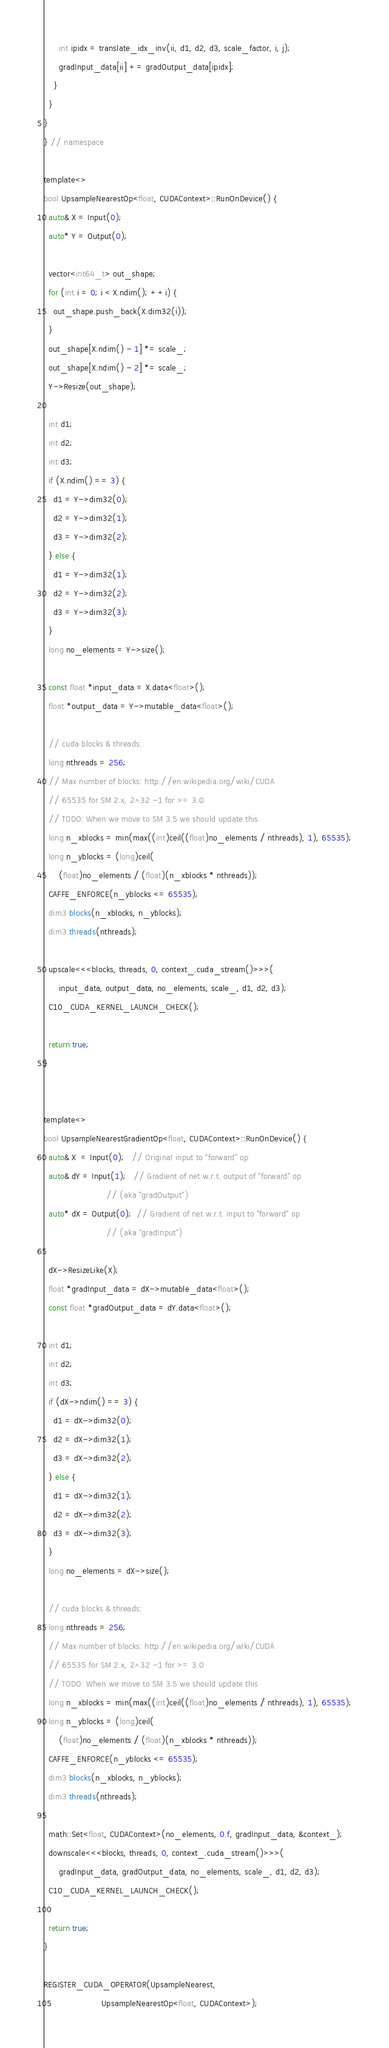<code> <loc_0><loc_0><loc_500><loc_500><_Cuda_>      int ipidx = translate_idx_inv(ii, d1, d2, d3, scale_factor, i, j);
      gradInput_data[ii] += gradOutput_data[ipidx];
    }
  }
}
} // namespace

template<>
bool UpsampleNearestOp<float, CUDAContext>::RunOnDevice() {
  auto& X = Input(0);
  auto* Y = Output(0);

  vector<int64_t> out_shape;
  for (int i = 0; i < X.ndim(); ++i) {
    out_shape.push_back(X.dim32(i));
  }
  out_shape[X.ndim() - 1] *= scale_;
  out_shape[X.ndim() - 2] *= scale_;
  Y->Resize(out_shape);

  int d1;
  int d2;
  int d3;
  if (X.ndim() == 3) {
    d1 = Y->dim32(0);
    d2 = Y->dim32(1);
    d3 = Y->dim32(2);
  } else {
    d1 = Y->dim32(1);
    d2 = Y->dim32(2);
    d3 = Y->dim32(3);
  }
  long no_elements = Y->size();

  const float *input_data = X.data<float>();
  float *output_data = Y->mutable_data<float>();

  // cuda blocks & threads:
  long nthreads = 256;
  // Max number of blocks: http://en.wikipedia.org/wiki/CUDA
  // 65535 for SM 2.x, 2^32 -1 for >= 3.0
  // TODO: When we move to SM 3.5 we should update this
  long n_xblocks = min(max((int)ceil((float)no_elements / nthreads), 1), 65535);
  long n_yblocks = (long)ceil(
      (float)no_elements / (float)(n_xblocks * nthreads));
  CAFFE_ENFORCE(n_yblocks <= 65535);
  dim3 blocks(n_xblocks, n_yblocks);
  dim3 threads(nthreads);

  upscale<<<blocks, threads, 0, context_.cuda_stream()>>>(
      input_data, output_data, no_elements, scale_, d1, d2, d3);
  C10_CUDA_KERNEL_LAUNCH_CHECK();

  return true;
}


template<>
bool UpsampleNearestGradientOp<float, CUDAContext>::RunOnDevice() {
  auto& X  = Input(0);   // Original input to "forward" op
  auto& dY = Input(1);   // Gradient of net w.r.t. output of "forward" op
                         // (aka "gradOutput")
  auto* dX = Output(0);  // Gradient of net w.r.t. input to "forward" op
                         // (aka "gradInput")

  dX->ResizeLike(X);
  float *gradInput_data = dX->mutable_data<float>();
  const float *gradOutput_data = dY.data<float>();

  int d1;
  int d2;
  int d3;
  if (dX->ndim() == 3) {
    d1 = dX->dim32(0);
    d2 = dX->dim32(1);
    d3 = dX->dim32(2);
  } else {
    d1 = dX->dim32(1);
    d2 = dX->dim32(2);
    d3 = dX->dim32(3);
  }
  long no_elements = dX->size();

  // cuda blocks & threads:
  long nthreads = 256;
  // Max number of blocks: http://en.wikipedia.org/wiki/CUDA
  // 65535 for SM 2.x, 2^32 -1 for >= 3.0
  // TODO: When we move to SM 3.5 we should update this
  long n_xblocks = min(max((int)ceil((float)no_elements / nthreads), 1), 65535);
  long n_yblocks = (long)ceil(
      (float)no_elements / (float)(n_xblocks * nthreads));
  CAFFE_ENFORCE(n_yblocks <= 65535);
  dim3 blocks(n_xblocks, n_yblocks);
  dim3 threads(nthreads);

  math::Set<float, CUDAContext>(no_elements, 0.f, gradInput_data, &context_);
  downscale<<<blocks, threads, 0, context_.cuda_stream()>>>(
      gradInput_data, gradOutput_data, no_elements, scale_, d1, d2, d3);
  C10_CUDA_KERNEL_LAUNCH_CHECK();

  return true;
}

REGISTER_CUDA_OPERATOR(UpsampleNearest,
                       UpsampleNearestOp<float, CUDAContext>);</code> 